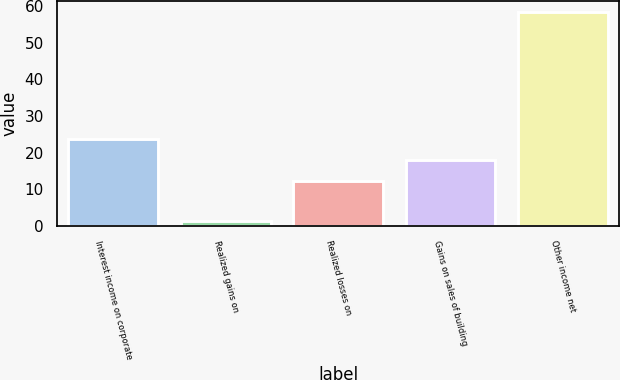Convert chart to OTSL. <chart><loc_0><loc_0><loc_500><loc_500><bar_chart><fcel>Interest income on corporate<fcel>Realized gains on<fcel>Realized losses on<fcel>Gains on sales of building<fcel>Other income net<nl><fcel>23.84<fcel>1.3<fcel>12.4<fcel>18.12<fcel>58.5<nl></chart> 